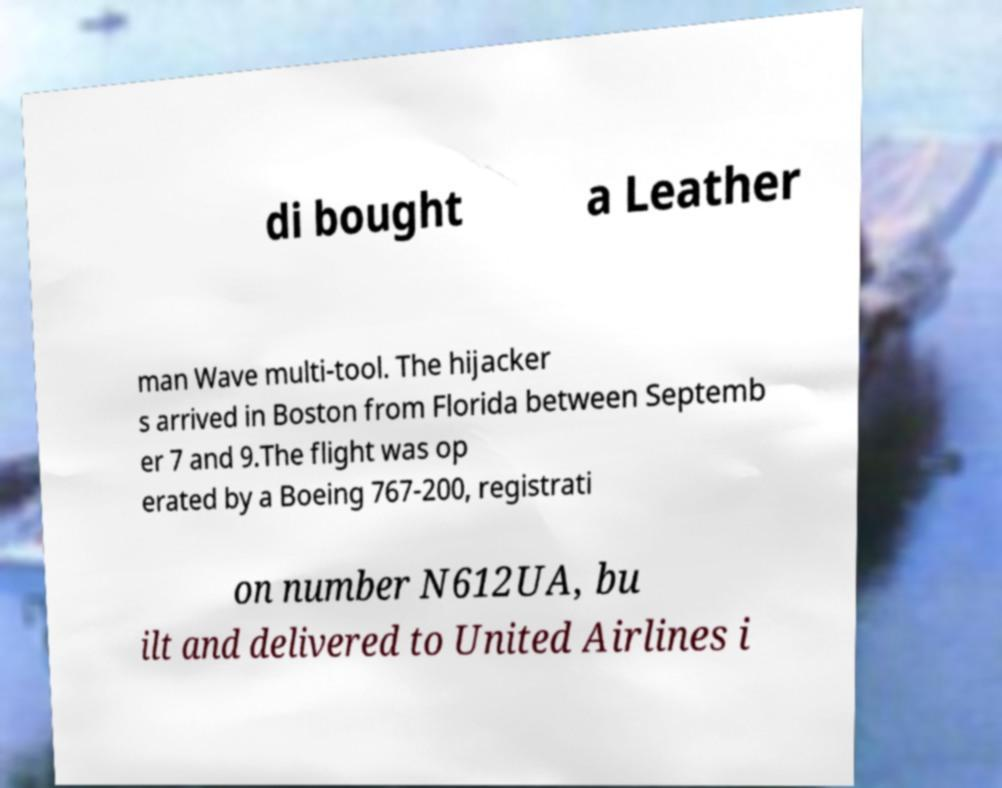Please identify and transcribe the text found in this image. di bought a Leather man Wave multi-tool. The hijacker s arrived in Boston from Florida between Septemb er 7 and 9.The flight was op erated by a Boeing 767-200, registrati on number N612UA, bu ilt and delivered to United Airlines i 